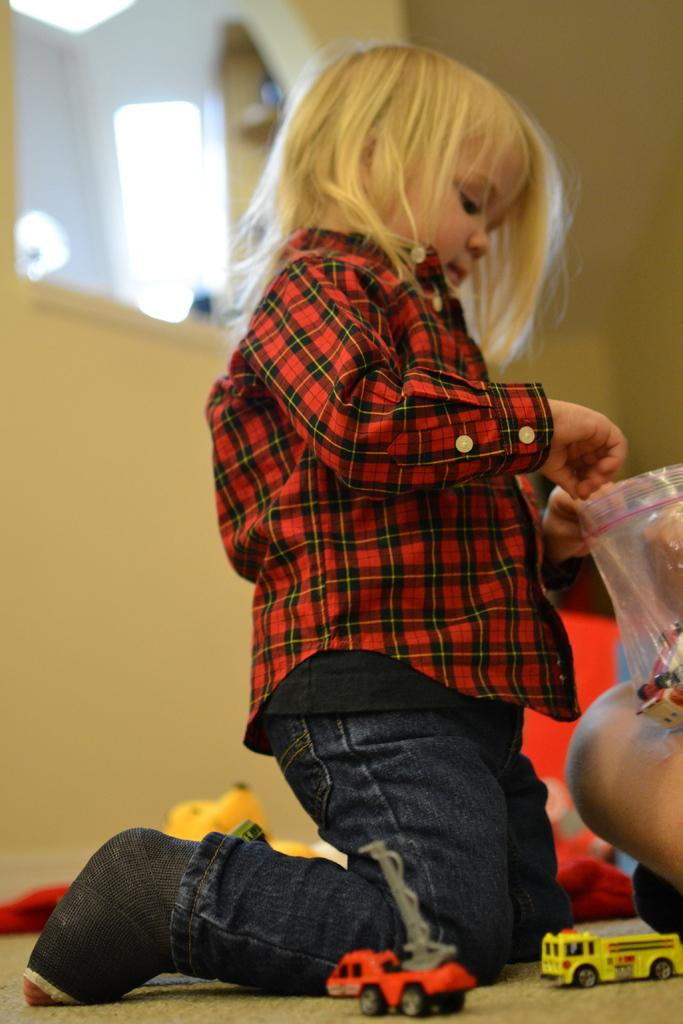What type of objects can be seen in the image? There are toys in the image. Where is the child located in the image? The child is on the floor in the image. What is covering the floor in the image? There is a plastic cover in the image. What else can be seen in the image besides the toys and child? There are objects in the image. What can be seen in the background of the image? There is a wall visible in the background of the image. What type of sand can be seen in the image? There is no sand present in the image. Is there a camera visible in the image? There is no camera visible in the image. 